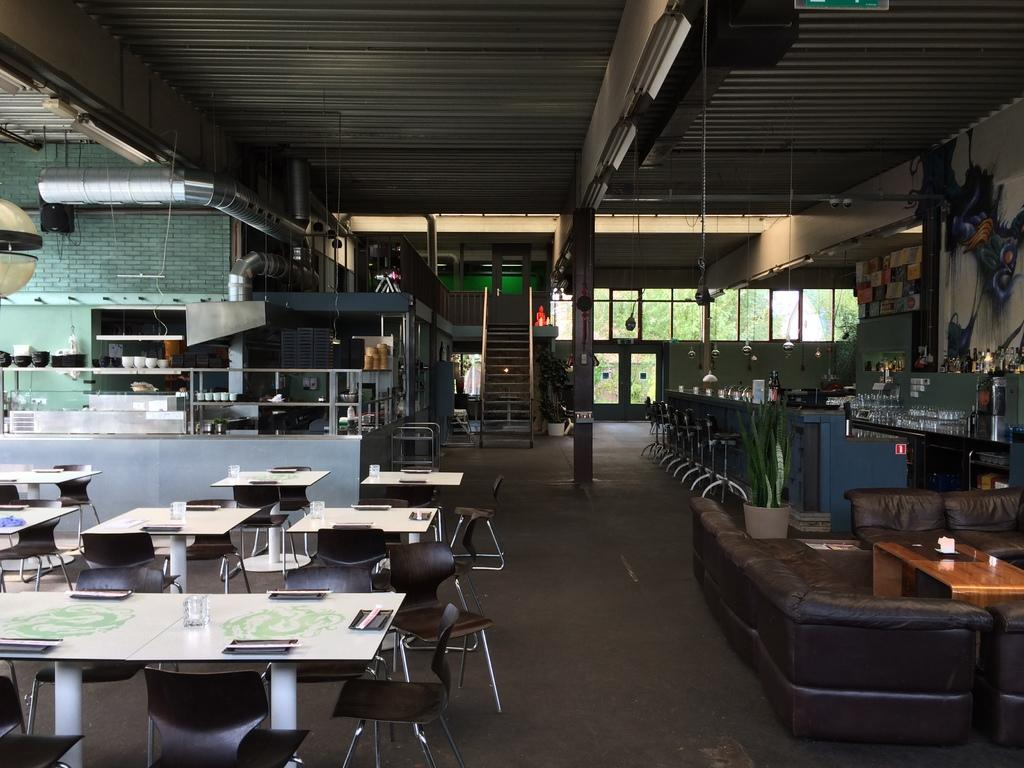What type of furniture is visible in the image? There are tables, chairs, and sofas in the image. What objects are on the tables? There are glasses on the tables. What architectural features can be seen in the background of the image? There are stairs and a door in the background of the image. What natural elements are visible in the background of the image? There are trees in the background of the image. What grade does the sofa receive in the image? The image does not depict a grading system for the sofa, so it cannot be graded. What type of love is shown between the chairs and the tables in the image? The image does not depict any emotions or relationships between the furniture, so it cannot be determined if love is present. 